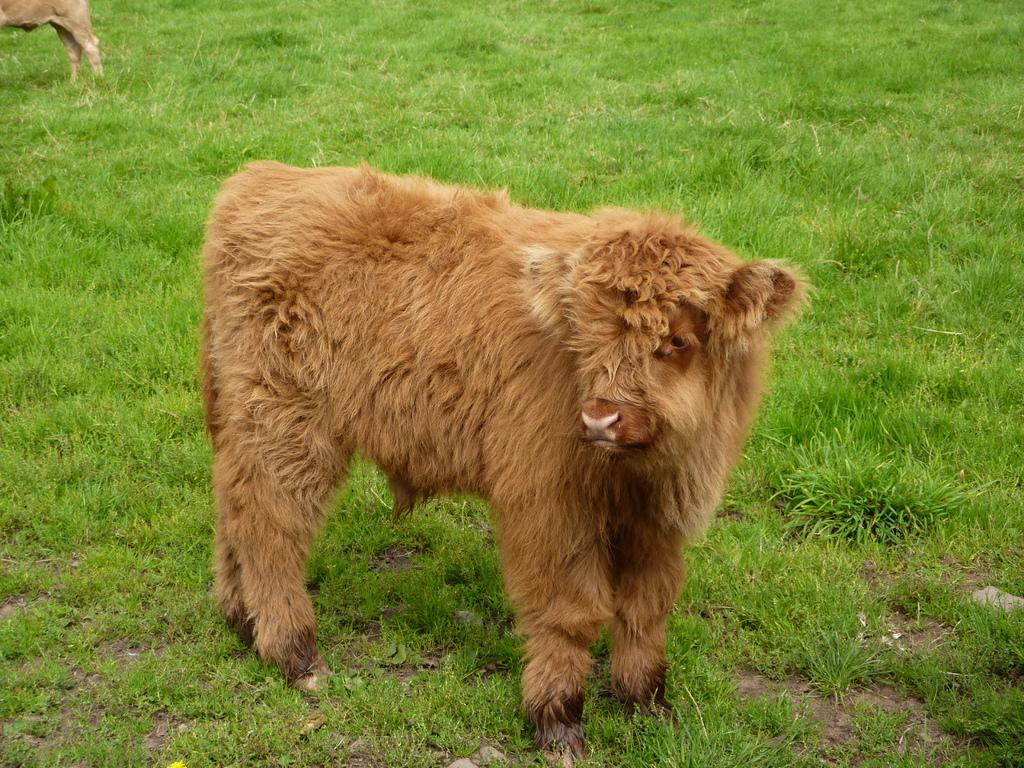How many animals are present in the image? There are two animals in the image. What is the position of the animals in the image? The animals are standing on the ground. What type of sign is the animal wearing in the image? There is no sign present in the image, as the animals are not wearing any apparel. 